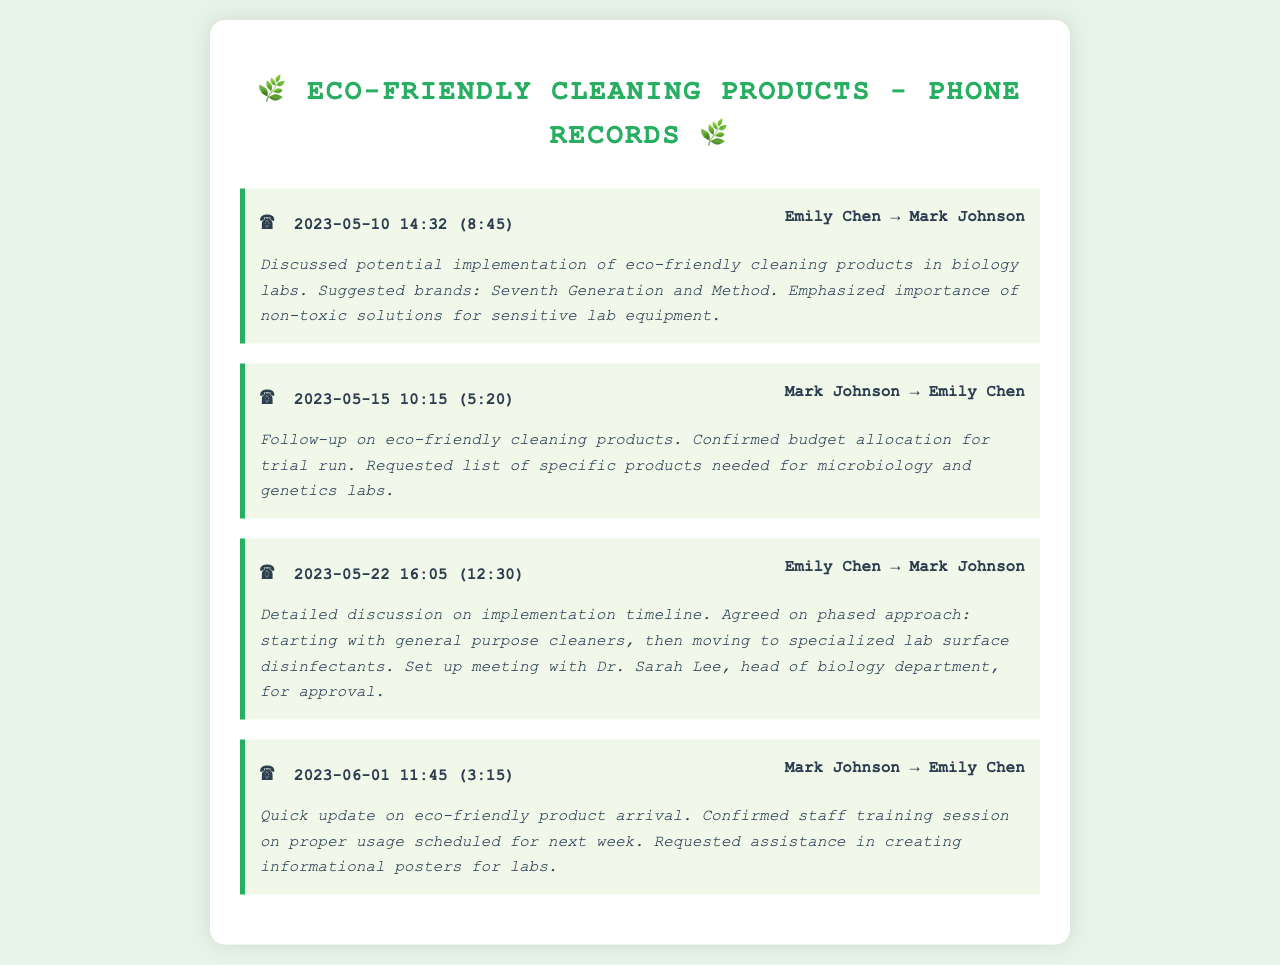What date was the first conversation about eco-friendly cleaning products? The first conversation recorded took place on May 10, 2023.
Answer: May 10, 2023 Who initiated the follow-up conversation on May 15? Mark Johnson was the one who reached out in the follow-up conversation.
Answer: Mark Johnson How long was the conversation on May 22? The conversation lasted 12 minutes and 30 seconds.
Answer: 12:30 What brands were suggested for eco-friendly cleaning products? Emily Chen suggested Seventh Generation and Method during the first conversation.
Answer: Seventh Generation and Method What was agreed upon during the conversation on May 22? They agreed on a phased approach for the implementation timeline of eco-friendly products.
Answer: Phased approach What was confirmed regarding the budget during the May 15 conversation? The budget allocation for a trial run of eco-friendly products was confirmed.
Answer: Budget allocation for trial run What was scheduled for the week following the update on June 1? A staff training session on proper usage of eco-friendly products was scheduled.
Answer: Staff training session Who was mentioned as needing to approve the implementation plans? Dr. Sarah Lee, head of the biology department, was mentioned for approval.
Answer: Dr. Sarah Lee What type of products were requested specifically for the microbiology and genetics labs? A list of specific eco-friendly products needed for those labs was requested.
Answer: Specific products needed for microbiology and genetics labs 